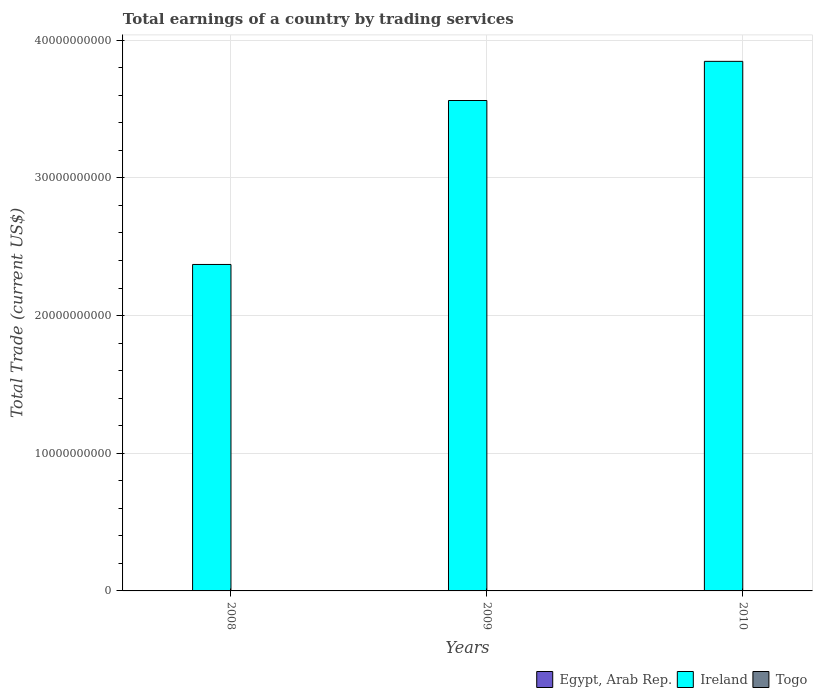How many different coloured bars are there?
Give a very brief answer. 1. Are the number of bars per tick equal to the number of legend labels?
Provide a short and direct response. No. What is the label of the 1st group of bars from the left?
Provide a succinct answer. 2008. What is the total earnings in Ireland in 2008?
Ensure brevity in your answer.  2.37e+1. Across all years, what is the maximum total earnings in Ireland?
Keep it short and to the point. 3.85e+1. Across all years, what is the minimum total earnings in Ireland?
Keep it short and to the point. 2.37e+1. What is the total total earnings in Ireland in the graph?
Your response must be concise. 9.78e+1. What is the difference between the total earnings in Ireland in 2008 and that in 2010?
Give a very brief answer. -1.48e+1. What is the difference between the total earnings in Egypt, Arab Rep. in 2010 and the total earnings in Togo in 2009?
Keep it short and to the point. 0. In how many years, is the total earnings in Togo greater than 10000000000 US$?
Keep it short and to the point. 0. What is the ratio of the total earnings in Ireland in 2008 to that in 2010?
Keep it short and to the point. 0.62. Is the total earnings in Ireland in 2009 less than that in 2010?
Your response must be concise. Yes. What is the difference between the highest and the second highest total earnings in Ireland?
Provide a succinct answer. 2.84e+09. What is the difference between the highest and the lowest total earnings in Ireland?
Provide a succinct answer. 1.48e+1. How many bars are there?
Offer a very short reply. 3. Are all the bars in the graph horizontal?
Ensure brevity in your answer.  No. How many years are there in the graph?
Your response must be concise. 3. Does the graph contain any zero values?
Make the answer very short. Yes. Does the graph contain grids?
Offer a terse response. Yes. How are the legend labels stacked?
Your answer should be very brief. Horizontal. What is the title of the graph?
Your answer should be compact. Total earnings of a country by trading services. What is the label or title of the X-axis?
Make the answer very short. Years. What is the label or title of the Y-axis?
Keep it short and to the point. Total Trade (current US$). What is the Total Trade (current US$) in Ireland in 2008?
Provide a short and direct response. 2.37e+1. What is the Total Trade (current US$) of Ireland in 2009?
Your response must be concise. 3.56e+1. What is the Total Trade (current US$) in Egypt, Arab Rep. in 2010?
Keep it short and to the point. 0. What is the Total Trade (current US$) in Ireland in 2010?
Offer a terse response. 3.85e+1. What is the Total Trade (current US$) in Togo in 2010?
Your response must be concise. 0. Across all years, what is the maximum Total Trade (current US$) of Ireland?
Give a very brief answer. 3.85e+1. Across all years, what is the minimum Total Trade (current US$) in Ireland?
Make the answer very short. 2.37e+1. What is the total Total Trade (current US$) in Egypt, Arab Rep. in the graph?
Keep it short and to the point. 0. What is the total Total Trade (current US$) in Ireland in the graph?
Provide a succinct answer. 9.78e+1. What is the total Total Trade (current US$) of Togo in the graph?
Offer a terse response. 0. What is the difference between the Total Trade (current US$) in Ireland in 2008 and that in 2009?
Make the answer very short. -1.19e+1. What is the difference between the Total Trade (current US$) in Ireland in 2008 and that in 2010?
Offer a very short reply. -1.48e+1. What is the difference between the Total Trade (current US$) of Ireland in 2009 and that in 2010?
Ensure brevity in your answer.  -2.84e+09. What is the average Total Trade (current US$) of Egypt, Arab Rep. per year?
Ensure brevity in your answer.  0. What is the average Total Trade (current US$) in Ireland per year?
Ensure brevity in your answer.  3.26e+1. What is the ratio of the Total Trade (current US$) in Ireland in 2008 to that in 2009?
Offer a terse response. 0.67. What is the ratio of the Total Trade (current US$) in Ireland in 2008 to that in 2010?
Offer a terse response. 0.62. What is the ratio of the Total Trade (current US$) in Ireland in 2009 to that in 2010?
Give a very brief answer. 0.93. What is the difference between the highest and the second highest Total Trade (current US$) in Ireland?
Provide a succinct answer. 2.84e+09. What is the difference between the highest and the lowest Total Trade (current US$) of Ireland?
Make the answer very short. 1.48e+1. 